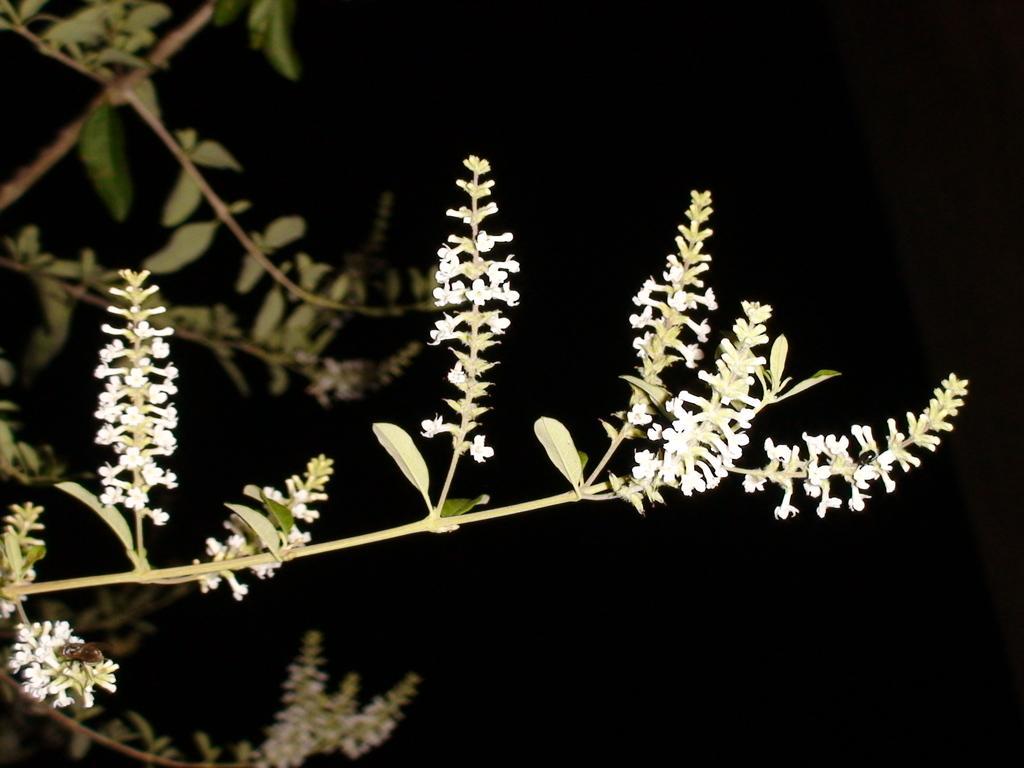Could you give a brief overview of what you see in this image? In this image there is a plant to which there are small flowers. In the background it is dark. On the left side top there are leaves. 